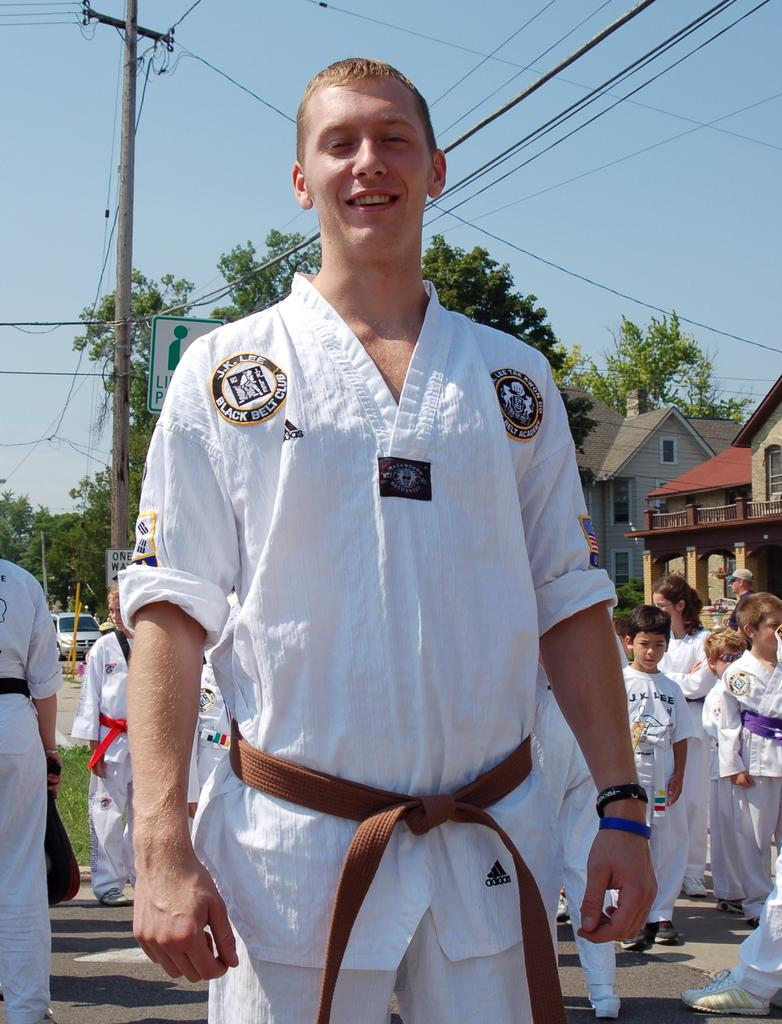<image>
Write a terse but informative summary of the picture. A young man is a member of the Black Belt Club. 